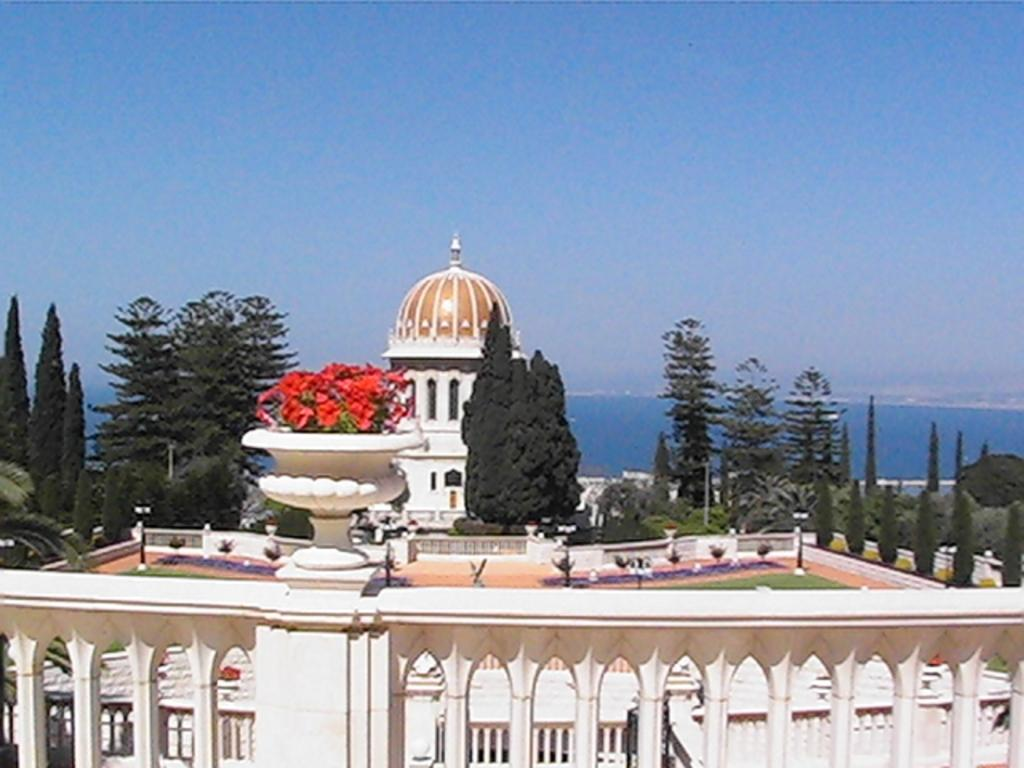What is located in the center of the image? There is a railing in the center of the image. What type of plant is visible in the image? There are flowers in a flower pot in the image. What can be seen in the background of the image? The sky, at least one building, trees, and a few other objects are present in the background of the image. What type of form is being filled out on the board in the image? There is no form or board present in the image. Where is the sink located in the image? There is no sink present in the image. 